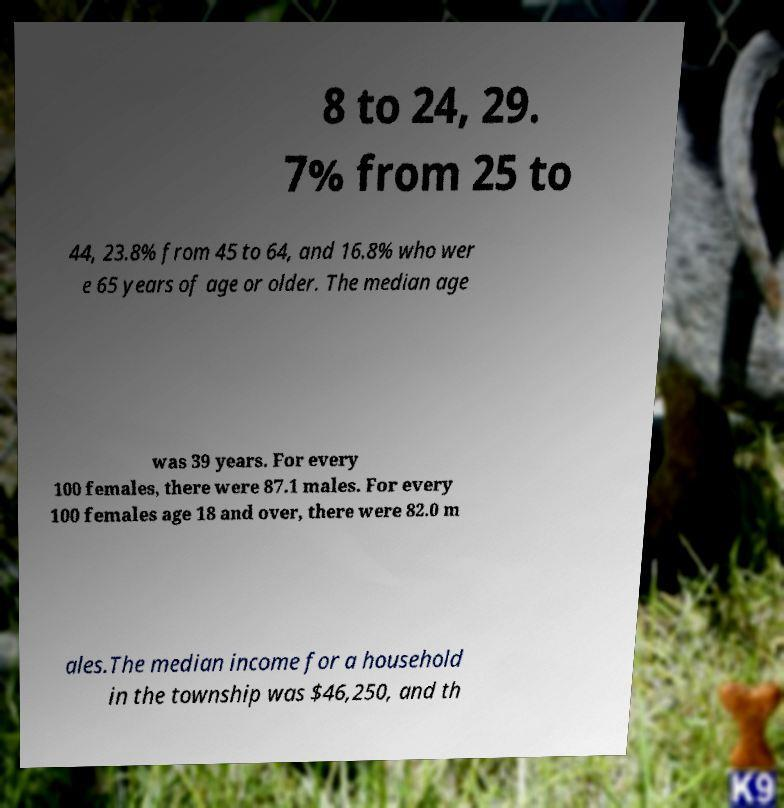Could you assist in decoding the text presented in this image and type it out clearly? 8 to 24, 29. 7% from 25 to 44, 23.8% from 45 to 64, and 16.8% who wer e 65 years of age or older. The median age was 39 years. For every 100 females, there were 87.1 males. For every 100 females age 18 and over, there were 82.0 m ales.The median income for a household in the township was $46,250, and th 